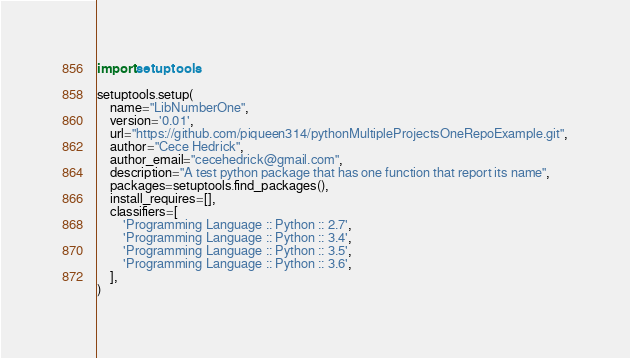<code> <loc_0><loc_0><loc_500><loc_500><_Python_>import setuptools

setuptools.setup(
    name="LibNumberOne",
    version='0.01',
    url="https://github.com/piqueen314/pythonMultipleProjectsOneRepoExample.git",
    author="Cece Hedrick",
    author_email="cecehedrick@gmail.com",
    description="A test python package that has one function that report its name",
    packages=setuptools.find_packages(),
    install_requires=[],
    classifiers=[
        'Programming Language :: Python :: 2.7',
        'Programming Language :: Python :: 3.4',
        'Programming Language :: Python :: 3.5',
        'Programming Language :: Python :: 3.6',
    ],
)</code> 